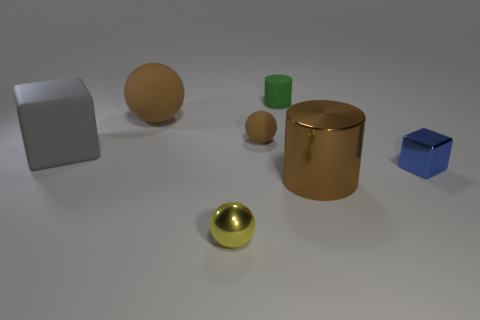Add 2 gray rubber objects. How many objects exist? 9 Subtract all spheres. How many objects are left? 4 Subtract 0 red balls. How many objects are left? 7 Subtract all small green cylinders. Subtract all small green matte things. How many objects are left? 5 Add 4 tiny metal objects. How many tiny metal objects are left? 6 Add 3 purple rubber objects. How many purple rubber objects exist? 3 